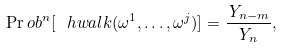<formula> <loc_0><loc_0><loc_500><loc_500>\Pr o b ^ { n } [ \ h w a l k ( \omega ^ { 1 } , \dots , \omega ^ { j } ) ] = \frac { \, Y _ { n - m } } { Y _ { n } } ,</formula> 